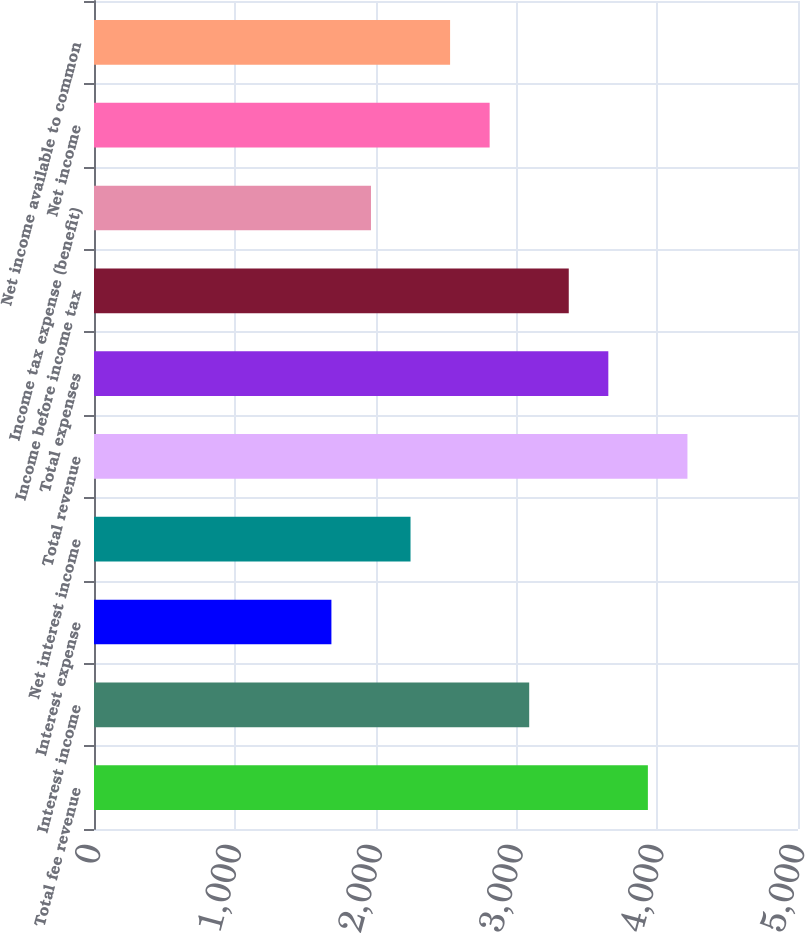<chart> <loc_0><loc_0><loc_500><loc_500><bar_chart><fcel>Total fee revenue<fcel>Interest income<fcel>Interest expense<fcel>Net interest income<fcel>Total revenue<fcel>Total expenses<fcel>Income before income tax<fcel>Income tax expense (benefit)<fcel>Net income<fcel>Net income available to common<nl><fcel>3933.82<fcel>3090.94<fcel>1686.14<fcel>2248.06<fcel>4214.78<fcel>3652.86<fcel>3371.9<fcel>1967.1<fcel>2809.98<fcel>2529.02<nl></chart> 